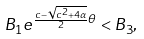Convert formula to latex. <formula><loc_0><loc_0><loc_500><loc_500>B _ { 1 } e ^ { \frac { c - \sqrt { c ^ { 2 } + 4 \alpha } } { 2 } \theta } < B _ { 3 } ,</formula> 